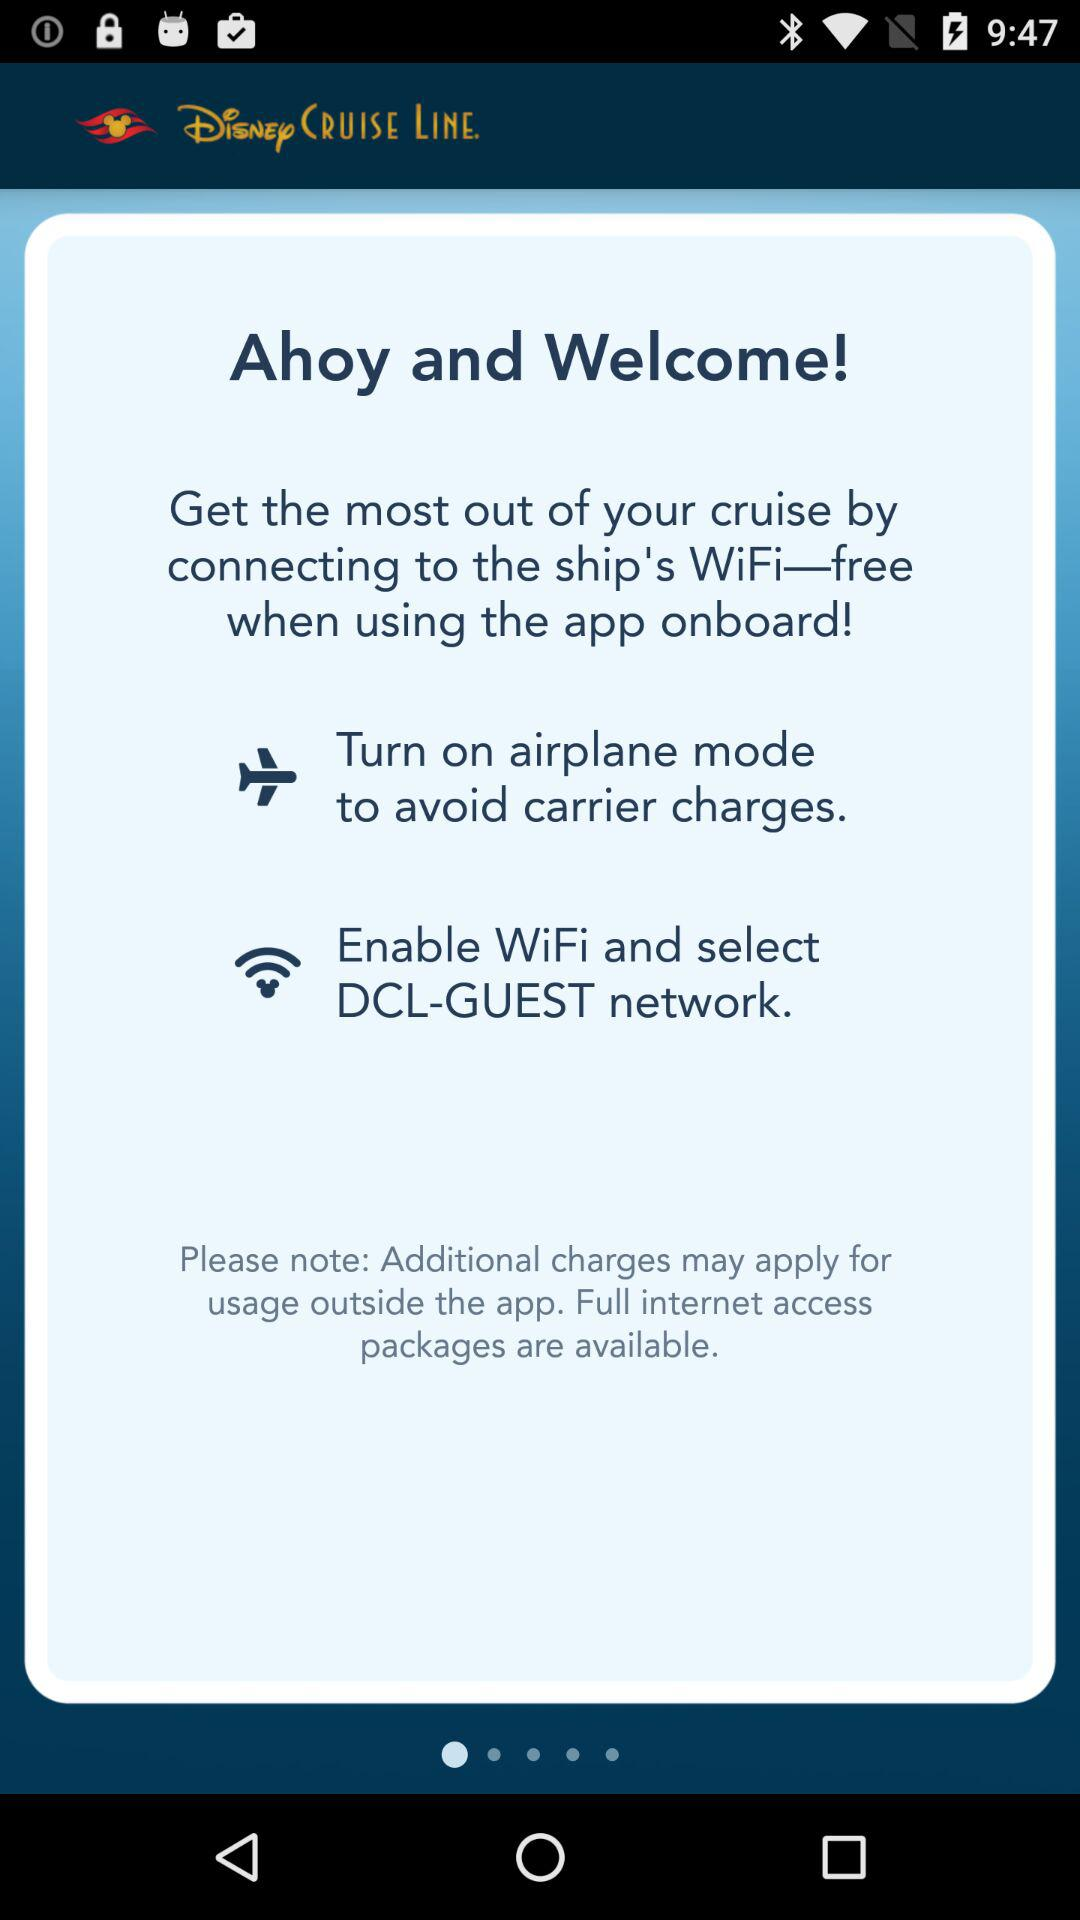What is the application name? The application name is "Disney CRUISE LINE.". 